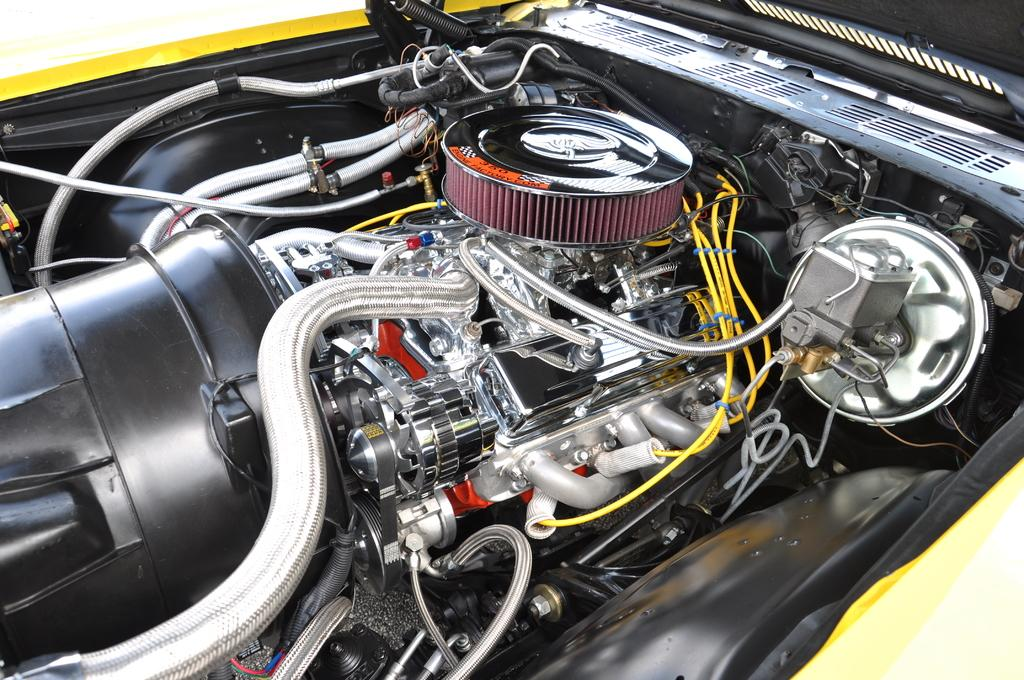What type of subject is featured in the image? The image contains internal parts of a vehicle. What time of day is it in the image, and are there any hydrants or rails visible? The time of day is not mentioned in the image, and there are no hydrants or rails visible; the image only features internal parts of a vehicle. 